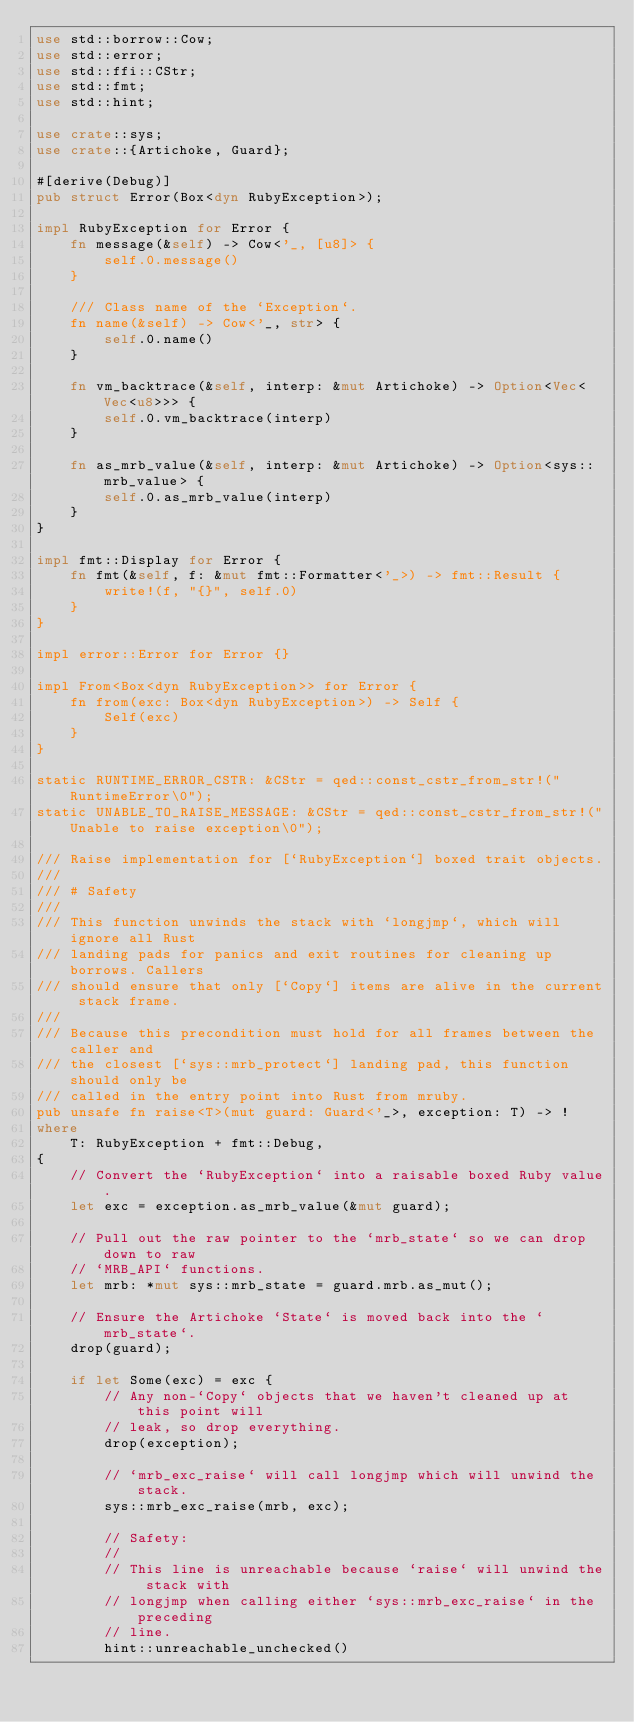Convert code to text. <code><loc_0><loc_0><loc_500><loc_500><_Rust_>use std::borrow::Cow;
use std::error;
use std::ffi::CStr;
use std::fmt;
use std::hint;

use crate::sys;
use crate::{Artichoke, Guard};

#[derive(Debug)]
pub struct Error(Box<dyn RubyException>);

impl RubyException for Error {
    fn message(&self) -> Cow<'_, [u8]> {
        self.0.message()
    }

    /// Class name of the `Exception`.
    fn name(&self) -> Cow<'_, str> {
        self.0.name()
    }

    fn vm_backtrace(&self, interp: &mut Artichoke) -> Option<Vec<Vec<u8>>> {
        self.0.vm_backtrace(interp)
    }

    fn as_mrb_value(&self, interp: &mut Artichoke) -> Option<sys::mrb_value> {
        self.0.as_mrb_value(interp)
    }
}

impl fmt::Display for Error {
    fn fmt(&self, f: &mut fmt::Formatter<'_>) -> fmt::Result {
        write!(f, "{}", self.0)
    }
}

impl error::Error for Error {}

impl From<Box<dyn RubyException>> for Error {
    fn from(exc: Box<dyn RubyException>) -> Self {
        Self(exc)
    }
}

static RUNTIME_ERROR_CSTR: &CStr = qed::const_cstr_from_str!("RuntimeError\0");
static UNABLE_TO_RAISE_MESSAGE: &CStr = qed::const_cstr_from_str!("Unable to raise exception\0");

/// Raise implementation for [`RubyException`] boxed trait objects.
///
/// # Safety
///
/// This function unwinds the stack with `longjmp`, which will ignore all Rust
/// landing pads for panics and exit routines for cleaning up borrows. Callers
/// should ensure that only [`Copy`] items are alive in the current stack frame.
///
/// Because this precondition must hold for all frames between the caller and
/// the closest [`sys::mrb_protect`] landing pad, this function should only be
/// called in the entry point into Rust from mruby.
pub unsafe fn raise<T>(mut guard: Guard<'_>, exception: T) -> !
where
    T: RubyException + fmt::Debug,
{
    // Convert the `RubyException` into a raisable boxed Ruby value.
    let exc = exception.as_mrb_value(&mut guard);

    // Pull out the raw pointer to the `mrb_state` so we can drop down to raw
    // `MRB_API` functions.
    let mrb: *mut sys::mrb_state = guard.mrb.as_mut();

    // Ensure the Artichoke `State` is moved back into the `mrb_state`.
    drop(guard);

    if let Some(exc) = exc {
        // Any non-`Copy` objects that we haven't cleaned up at this point will
        // leak, so drop everything.
        drop(exception);

        // `mrb_exc_raise` will call longjmp which will unwind the stack.
        sys::mrb_exc_raise(mrb, exc);

        // Safety:
        //
        // This line is unreachable because `raise` will unwind the stack with
        // longjmp when calling either `sys::mrb_exc_raise` in the preceding
        // line.
        hint::unreachable_unchecked()</code> 